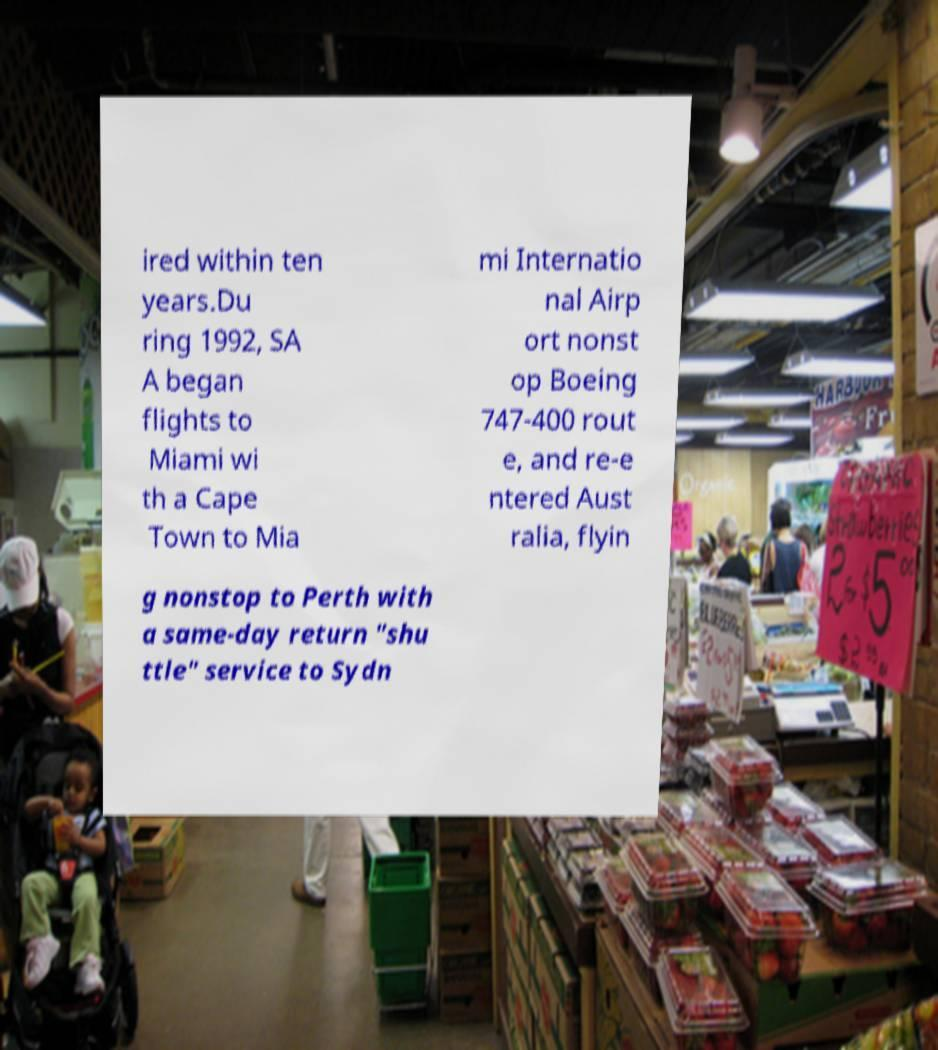Please read and relay the text visible in this image. What does it say? ired within ten years.Du ring 1992, SA A began flights to Miami wi th a Cape Town to Mia mi Internatio nal Airp ort nonst op Boeing 747-400 rout e, and re-e ntered Aust ralia, flyin g nonstop to Perth with a same-day return "shu ttle" service to Sydn 